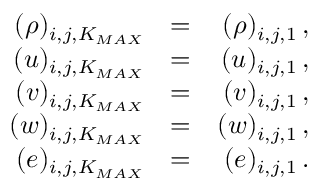Convert formula to latex. <formula><loc_0><loc_0><loc_500><loc_500>\begin{array} { r l r } { ( \rho ) _ { i , j , K _ { M A X } } } & { = } & { ( \rho ) _ { i , j , 1 } \, , } \\ { ( u ) _ { i , j , K _ { M A X } } } & { = } & { ( u ) _ { i , j , 1 } \, , } \\ { ( v ) _ { i , j , K _ { M A X } } } & { = } & { ( v ) _ { i , j , 1 } \, , } \\ { ( w ) _ { i , j , K _ { M A X } } } & { = } & { ( w ) _ { i , j , 1 } \, , } \\ { ( e ) _ { i , j , K _ { M A X } } } & { = } & { ( e ) _ { i , j , 1 } \, . } \end{array}</formula> 